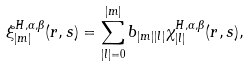Convert formula to latex. <formula><loc_0><loc_0><loc_500><loc_500>\xi _ { | m | } ^ { H , \alpha , \beta } ( r , s ) = \sum _ { | l | = 0 } ^ { | m | } b _ { | m | | l | } \chi _ { | l | } ^ { H , \alpha , \beta } ( r , s ) ,</formula> 